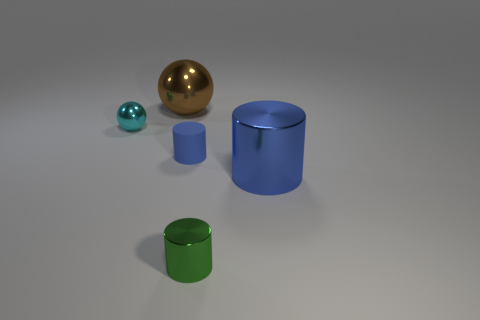Does the green shiny object have the same size as the blue thing in front of the small blue matte cylinder?
Your answer should be very brief. No. Is the big object that is in front of the cyan object made of the same material as the tiny thing that is to the left of the small rubber cylinder?
Make the answer very short. Yes. Are there the same number of big brown metallic balls left of the big brown thing and tiny cyan spheres on the right side of the matte cylinder?
Your answer should be very brief. Yes. How many tiny cylinders have the same color as the large cylinder?
Provide a succinct answer. 1. There is a object that is the same color as the small rubber cylinder; what is it made of?
Your answer should be very brief. Metal. How many shiny objects are either big spheres or small balls?
Keep it short and to the point. 2. Is the shape of the tiny thing behind the small matte thing the same as the small object to the right of the blue rubber cylinder?
Ensure brevity in your answer.  No. What number of cyan metal spheres are right of the tiny green metal cylinder?
Make the answer very short. 0. Are there any small blue objects made of the same material as the small green cylinder?
Offer a very short reply. No. There is a cyan sphere that is the same size as the green thing; what is its material?
Keep it short and to the point. Metal. 